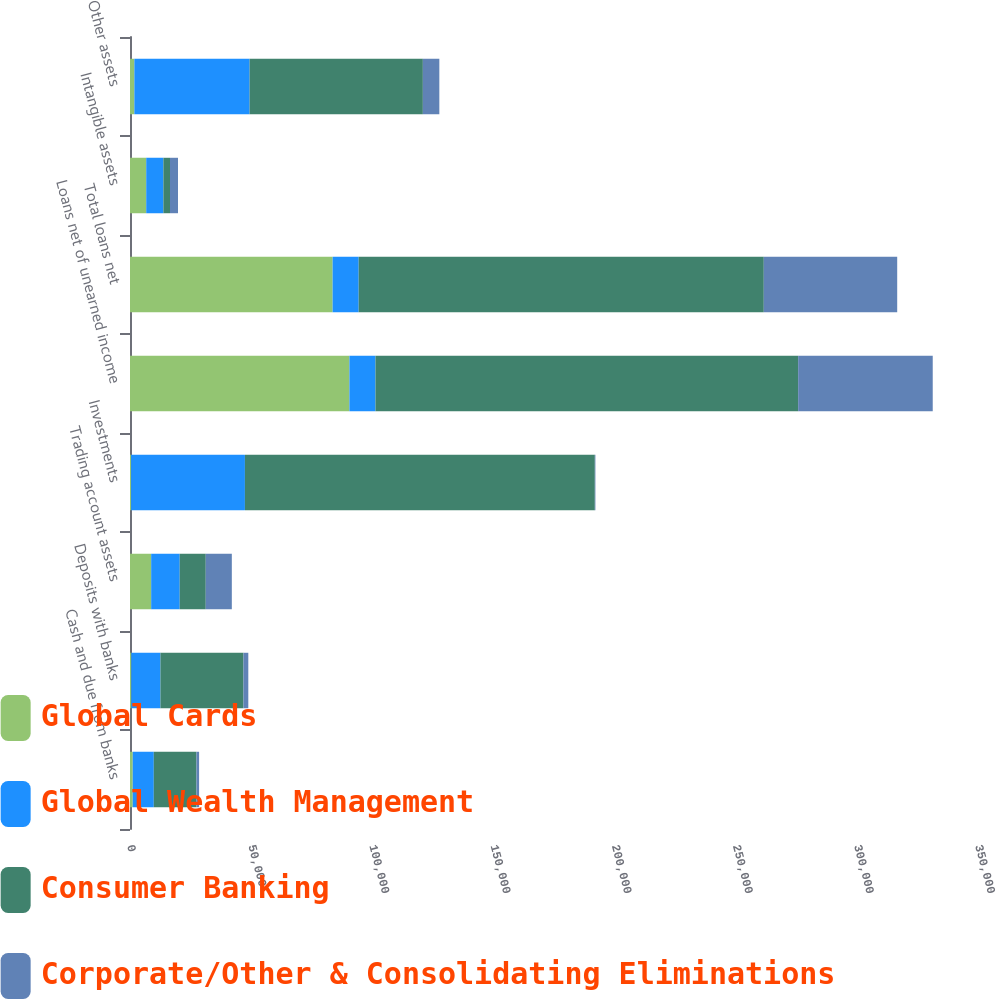Convert chart to OTSL. <chart><loc_0><loc_0><loc_500><loc_500><stacked_bar_chart><ecel><fcel>Cash and due from banks<fcel>Deposits with banks<fcel>Trading account assets<fcel>Investments<fcel>Loans net of unearned income<fcel>Total loans net<fcel>Intangible assets<fcel>Other assets<nl><fcel>Global Cards<fcel>1136<fcel>535<fcel>8737<fcel>450<fcel>90562<fcel>83630<fcel>6696<fcel>1797<nl><fcel>Global Wealth Management<fcel>8683<fcel>12030<fcel>11780<fcel>46984<fcel>10755<fcel>10755<fcel>7085<fcel>47572<nl><fcel>Consumer Banking<fcel>17599<fcel>34250<fcel>10755<fcel>144413<fcel>174455<fcel>167205<fcel>2730<fcel>71506<nl><fcel>Corporate/Other & Consolidating Eliminations<fcel>1103<fcel>2016<fcel>10755<fcel>244<fcel>55545<fcel>55061<fcel>3299<fcel>6801<nl></chart> 